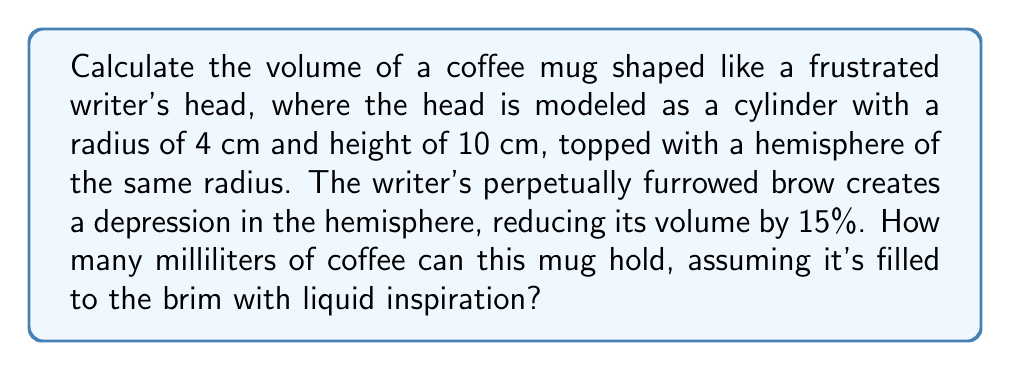Show me your answer to this math problem. Let's approach this problem step-by-step:

1) First, we need to calculate the volume of the cylindrical part of the mug:
   $$V_{cylinder} = \pi r^2 h$$
   $$V_{cylinder} = \pi (4\text{ cm})^2 (10\text{ cm}) = 160\pi\text{ cm}^3$$

2) Next, we calculate the volume of a full hemisphere:
   $$V_{hemisphere} = \frac{2}{3}\pi r^3$$
   $$V_{hemisphere} = \frac{2}{3}\pi (4\text{ cm})^3 = \frac{128\pi}{3}\text{ cm}^3$$

3) However, the writer's furrowed brow reduces this volume by 15%:
   $$V_{reduced\_hemisphere} = \frac{128\pi}{3}\text{ cm}^3 \times 0.85 = \frac{108.8\pi}{3}\text{ cm}^3$$

4) Now, we sum the volumes of the cylinder and the reduced hemisphere:
   $$V_{total} = V_{cylinder} + V_{reduced\_hemisphere}$$
   $$V_{total} = 160\pi\text{ cm}^3 + \frac{108.8\pi}{3}\text{ cm}^3 = \frac{588.8\pi}{3}\text{ cm}^3$$

5) To convert cubic centimeters to milliliters, we multiply by 1 (since 1 cm³ = 1 mL):
   $$V_{total} = \frac{588.8\pi}{3}\text{ mL} \approx 616.11\text{ mL}$$

[asy]
import three;

size(200);
currentprojection=perspective(6,3,2);

// Draw cylinder
draw(cylinder((0,0,0),4,10));

// Draw hemisphere
path3 p=arc((4,0,10),(0,4,10),(-4,0,10));
surface s=surface(p,cycle=true);
draw(s,paleblue);

// Draw depression
draw((3,0,13.5)--(0,0,14)--(-3,0,13.5),red);

label("4 cm",(-5,0,5),W);
label("10 cm",(4,-1,5),E);
[/asy]
Answer: 616.11 mL 